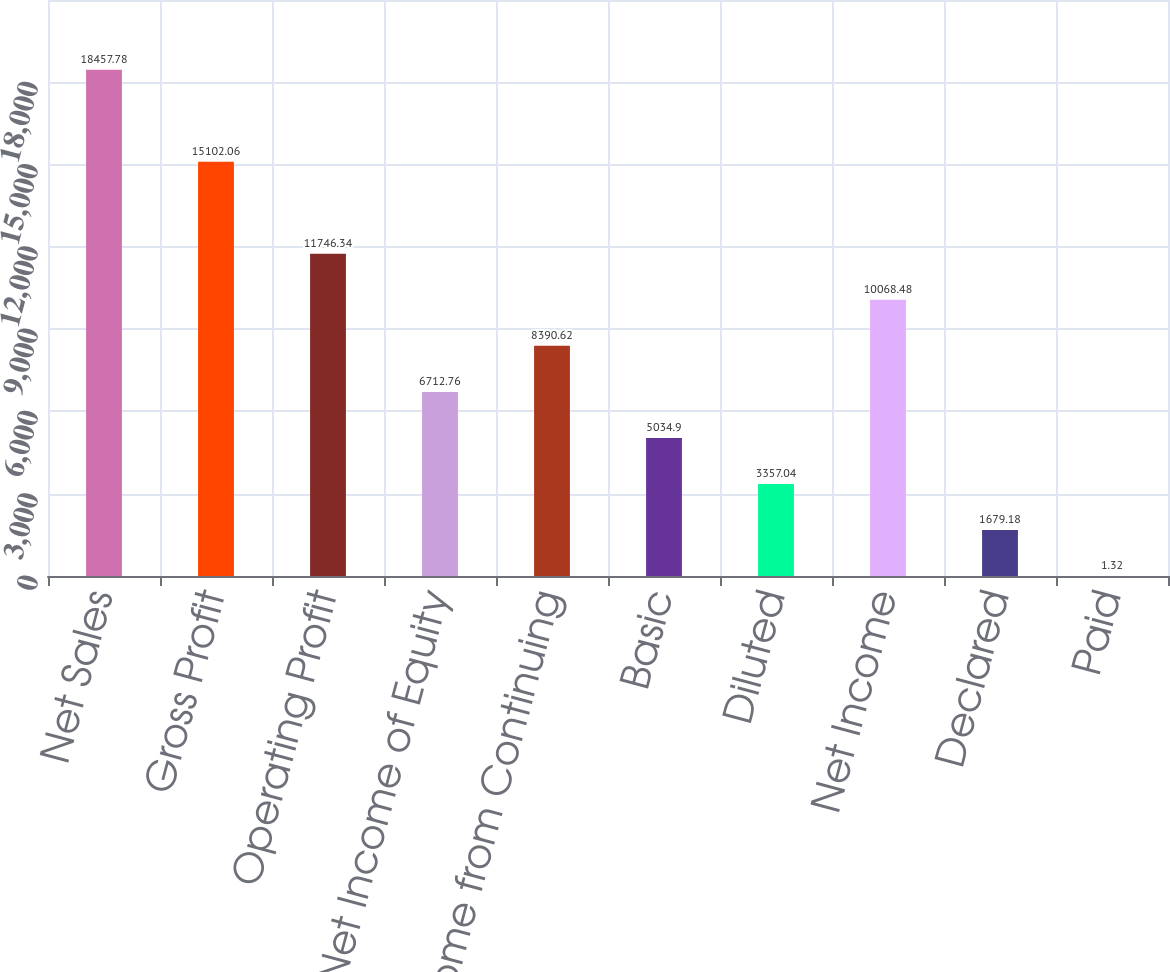<chart> <loc_0><loc_0><loc_500><loc_500><bar_chart><fcel>Net Sales<fcel>Gross Profit<fcel>Operating Profit<fcel>Share of Net Income of Equity<fcel>Income from Continuing<fcel>Basic<fcel>Diluted<fcel>Net Income<fcel>Declared<fcel>Paid<nl><fcel>18457.8<fcel>15102.1<fcel>11746.3<fcel>6712.76<fcel>8390.62<fcel>5034.9<fcel>3357.04<fcel>10068.5<fcel>1679.18<fcel>1.32<nl></chart> 